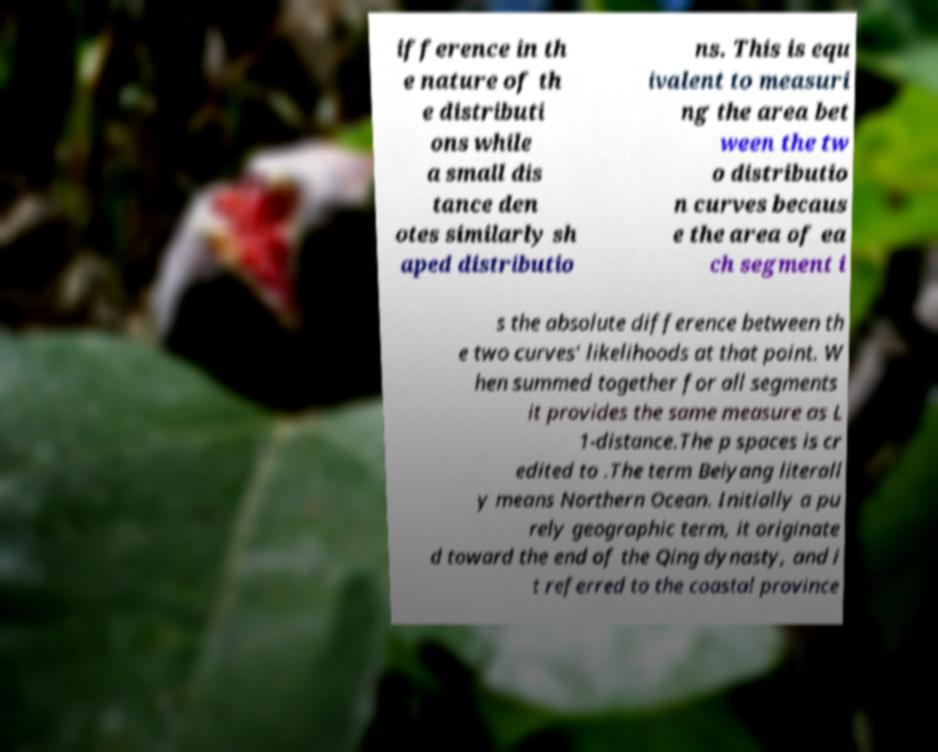What messages or text are displayed in this image? I need them in a readable, typed format. ifference in th e nature of th e distributi ons while a small dis tance den otes similarly sh aped distributio ns. This is equ ivalent to measuri ng the area bet ween the tw o distributio n curves becaus e the area of ea ch segment i s the absolute difference between th e two curves' likelihoods at that point. W hen summed together for all segments it provides the same measure as L 1-distance.The p spaces is cr edited to .The term Beiyang literall y means Northern Ocean. Initially a pu rely geographic term, it originate d toward the end of the Qing dynasty, and i t referred to the coastal province 